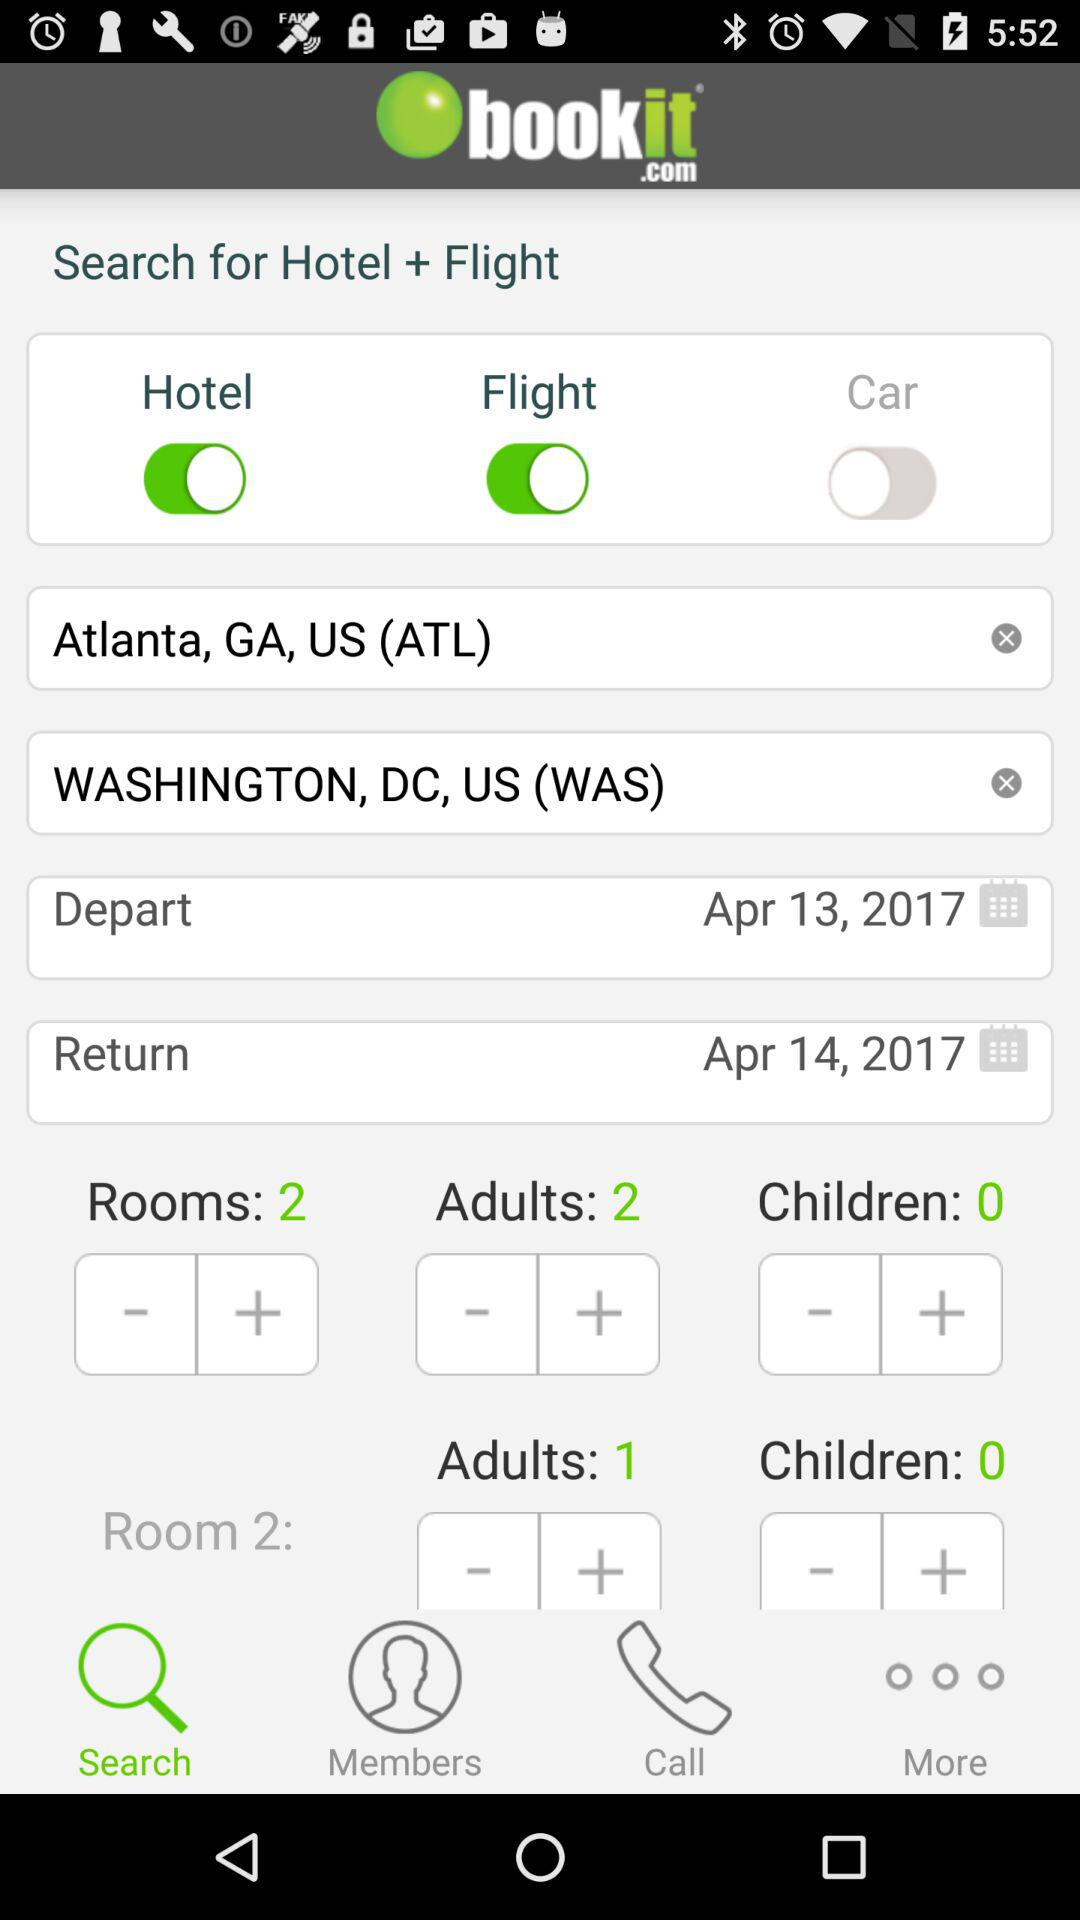What is the origin of the flight? The origin of the flight is Atlanta, GA, US (ATL). 